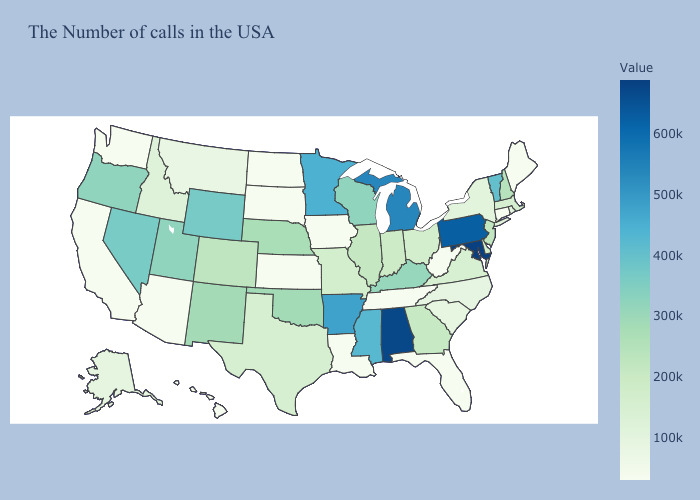Which states have the lowest value in the USA?
Answer briefly. Maine, Connecticut, West Virginia, Florida, Tennessee, Louisiana, Iowa, Kansas, South Dakota, North Dakota, Arizona, California, Washington, Hawaii. Which states have the lowest value in the MidWest?
Keep it brief. Iowa, Kansas, South Dakota, North Dakota. Does Rhode Island have the lowest value in the USA?
Short answer required. No. 